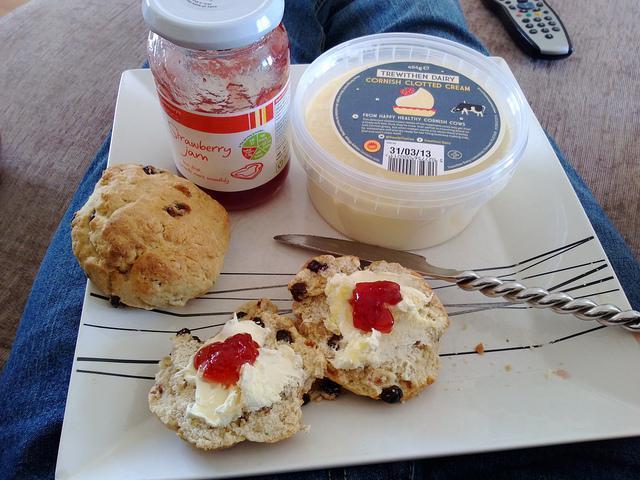How many clock faces do you see?
Give a very brief answer. 0. 